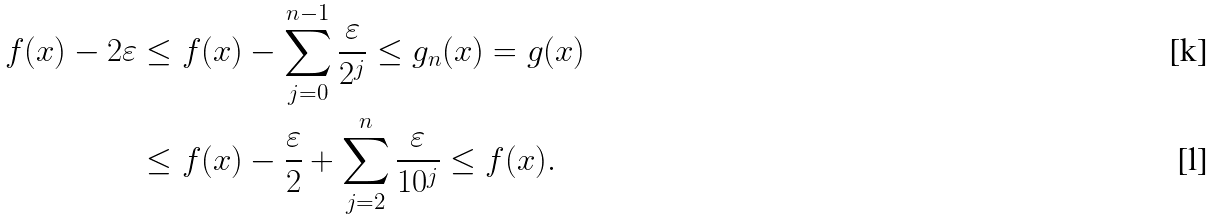Convert formula to latex. <formula><loc_0><loc_0><loc_500><loc_500>f ( x ) - 2 \varepsilon & \leq f ( x ) - \sum _ { j = 0 } ^ { n - 1 } \frac { \varepsilon } { 2 ^ { j } } \leq g _ { n } ( x ) = g ( x ) \\ & \leq f ( x ) - \frac { \varepsilon } { 2 } + \sum _ { j = 2 } ^ { n } \frac { \varepsilon } { 1 0 ^ { j } } \leq f ( x ) .</formula> 